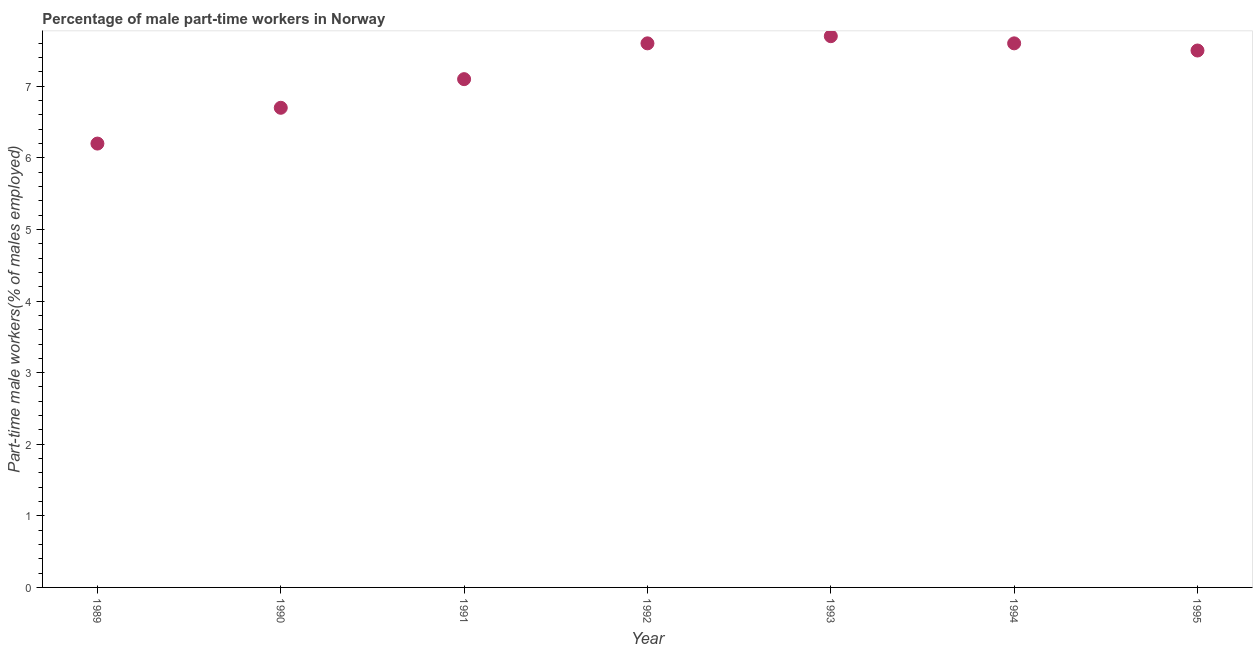Across all years, what is the maximum percentage of part-time male workers?
Offer a very short reply. 7.7. Across all years, what is the minimum percentage of part-time male workers?
Your answer should be very brief. 6.2. What is the sum of the percentage of part-time male workers?
Give a very brief answer. 50.4. What is the difference between the percentage of part-time male workers in 1994 and 1995?
Give a very brief answer. 0.1. What is the average percentage of part-time male workers per year?
Keep it short and to the point. 7.2. What is the median percentage of part-time male workers?
Your answer should be very brief. 7.5. In how many years, is the percentage of part-time male workers greater than 1.6 %?
Offer a terse response. 7. What is the ratio of the percentage of part-time male workers in 1993 to that in 1995?
Give a very brief answer. 1.03. Is the difference between the percentage of part-time male workers in 1990 and 1995 greater than the difference between any two years?
Make the answer very short. No. What is the difference between the highest and the second highest percentage of part-time male workers?
Your response must be concise. 0.1. Is the sum of the percentage of part-time male workers in 1992 and 1993 greater than the maximum percentage of part-time male workers across all years?
Your answer should be very brief. Yes. What is the difference between the highest and the lowest percentage of part-time male workers?
Your answer should be very brief. 1.5. In how many years, is the percentage of part-time male workers greater than the average percentage of part-time male workers taken over all years?
Give a very brief answer. 4. Are the values on the major ticks of Y-axis written in scientific E-notation?
Make the answer very short. No. Does the graph contain grids?
Your answer should be very brief. No. What is the title of the graph?
Offer a very short reply. Percentage of male part-time workers in Norway. What is the label or title of the Y-axis?
Provide a short and direct response. Part-time male workers(% of males employed). What is the Part-time male workers(% of males employed) in 1989?
Provide a succinct answer. 6.2. What is the Part-time male workers(% of males employed) in 1990?
Your response must be concise. 6.7. What is the Part-time male workers(% of males employed) in 1991?
Your response must be concise. 7.1. What is the Part-time male workers(% of males employed) in 1992?
Ensure brevity in your answer.  7.6. What is the Part-time male workers(% of males employed) in 1993?
Provide a succinct answer. 7.7. What is the Part-time male workers(% of males employed) in 1994?
Your answer should be compact. 7.6. What is the difference between the Part-time male workers(% of males employed) in 1989 and 1993?
Your response must be concise. -1.5. What is the difference between the Part-time male workers(% of males employed) in 1990 and 1991?
Your answer should be compact. -0.4. What is the difference between the Part-time male workers(% of males employed) in 1990 and 1992?
Your response must be concise. -0.9. What is the difference between the Part-time male workers(% of males employed) in 1992 and 1994?
Provide a short and direct response. 0. What is the difference between the Part-time male workers(% of males employed) in 1992 and 1995?
Offer a terse response. 0.1. What is the difference between the Part-time male workers(% of males employed) in 1993 and 1994?
Provide a succinct answer. 0.1. What is the ratio of the Part-time male workers(% of males employed) in 1989 to that in 1990?
Give a very brief answer. 0.93. What is the ratio of the Part-time male workers(% of males employed) in 1989 to that in 1991?
Offer a terse response. 0.87. What is the ratio of the Part-time male workers(% of males employed) in 1989 to that in 1992?
Your answer should be very brief. 0.82. What is the ratio of the Part-time male workers(% of males employed) in 1989 to that in 1993?
Give a very brief answer. 0.81. What is the ratio of the Part-time male workers(% of males employed) in 1989 to that in 1994?
Your answer should be compact. 0.82. What is the ratio of the Part-time male workers(% of males employed) in 1989 to that in 1995?
Offer a terse response. 0.83. What is the ratio of the Part-time male workers(% of males employed) in 1990 to that in 1991?
Your answer should be compact. 0.94. What is the ratio of the Part-time male workers(% of males employed) in 1990 to that in 1992?
Provide a short and direct response. 0.88. What is the ratio of the Part-time male workers(% of males employed) in 1990 to that in 1993?
Your answer should be compact. 0.87. What is the ratio of the Part-time male workers(% of males employed) in 1990 to that in 1994?
Your response must be concise. 0.88. What is the ratio of the Part-time male workers(% of males employed) in 1990 to that in 1995?
Offer a terse response. 0.89. What is the ratio of the Part-time male workers(% of males employed) in 1991 to that in 1992?
Provide a succinct answer. 0.93. What is the ratio of the Part-time male workers(% of males employed) in 1991 to that in 1993?
Your answer should be compact. 0.92. What is the ratio of the Part-time male workers(% of males employed) in 1991 to that in 1994?
Your answer should be very brief. 0.93. What is the ratio of the Part-time male workers(% of males employed) in 1991 to that in 1995?
Provide a short and direct response. 0.95. What is the ratio of the Part-time male workers(% of males employed) in 1992 to that in 1993?
Your answer should be compact. 0.99. What is the ratio of the Part-time male workers(% of males employed) in 1992 to that in 1995?
Your answer should be very brief. 1.01. What is the ratio of the Part-time male workers(% of males employed) in 1993 to that in 1995?
Offer a very short reply. 1.03. What is the ratio of the Part-time male workers(% of males employed) in 1994 to that in 1995?
Your response must be concise. 1.01. 